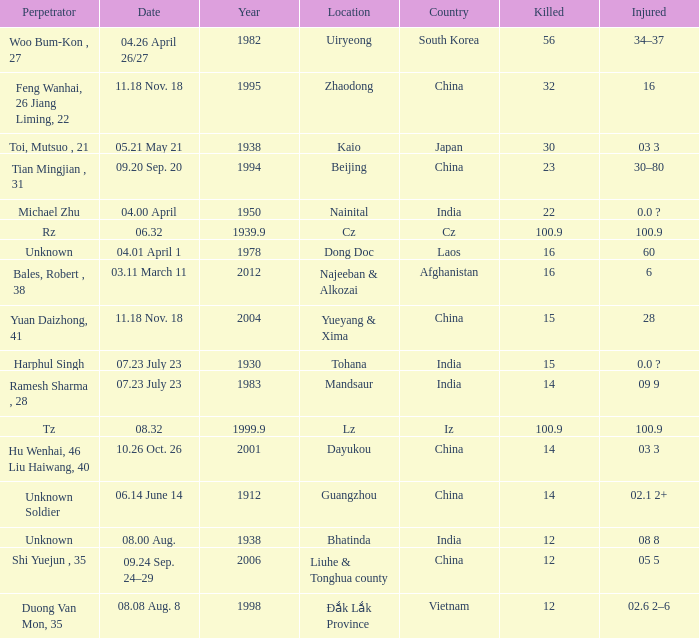What is hurt, when territory is "afghanistan"? 6.0. 